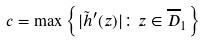<formula> <loc_0><loc_0><loc_500><loc_500>c = \max \left \{ | \tilde { h } ^ { \prime } ( z ) | \colon z \in \overline { D } _ { 1 } \right \}</formula> 